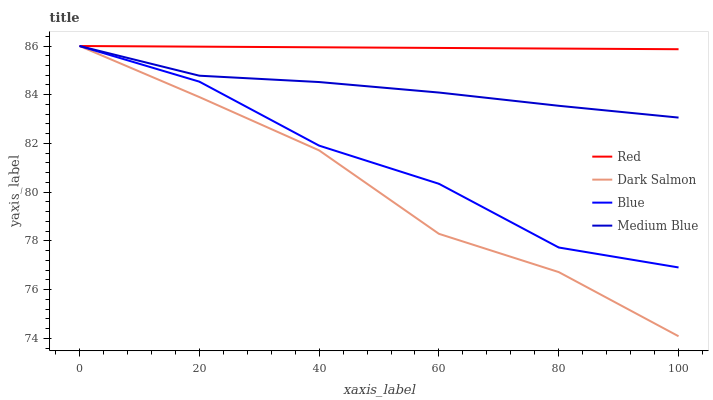Does Dark Salmon have the minimum area under the curve?
Answer yes or no. Yes. Does Red have the maximum area under the curve?
Answer yes or no. Yes. Does Medium Blue have the minimum area under the curve?
Answer yes or no. No. Does Medium Blue have the maximum area under the curve?
Answer yes or no. No. Is Red the smoothest?
Answer yes or no. Yes. Is Blue the roughest?
Answer yes or no. Yes. Is Medium Blue the smoothest?
Answer yes or no. No. Is Medium Blue the roughest?
Answer yes or no. No. Does Dark Salmon have the lowest value?
Answer yes or no. Yes. Does Medium Blue have the lowest value?
Answer yes or no. No. Does Red have the highest value?
Answer yes or no. Yes. Does Medium Blue intersect Blue?
Answer yes or no. Yes. Is Medium Blue less than Blue?
Answer yes or no. No. Is Medium Blue greater than Blue?
Answer yes or no. No. 